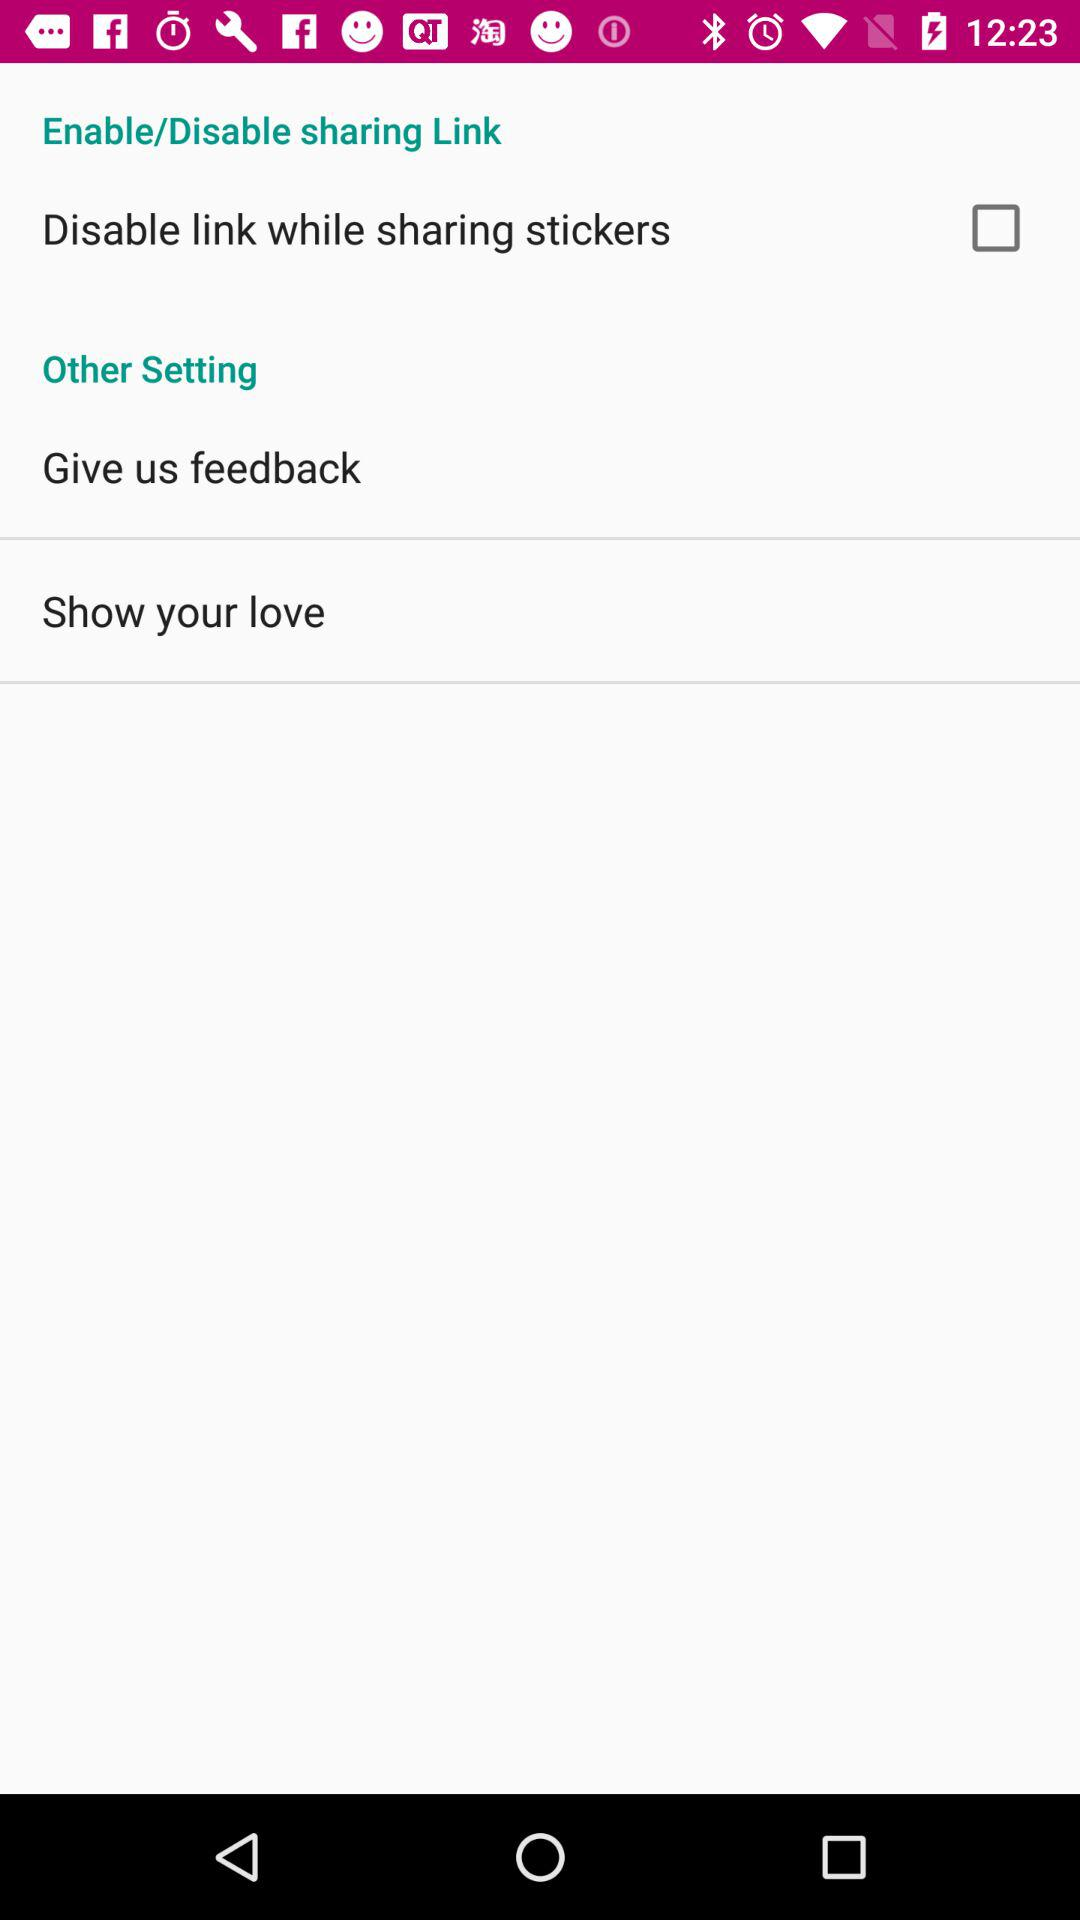What is the status of the "Disable link while sharing stickers"? The status is "off". 